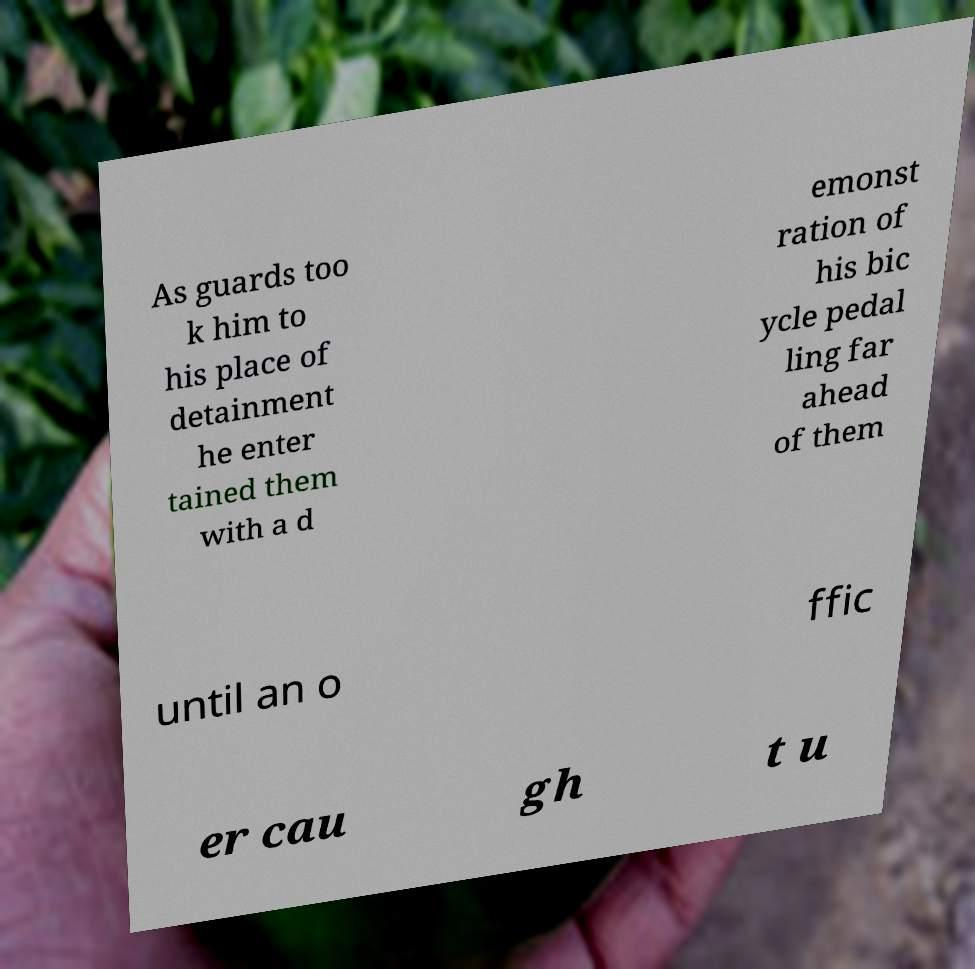Could you extract and type out the text from this image? As guards too k him to his place of detainment he enter tained them with a d emonst ration of his bic ycle pedal ling far ahead of them until an o ffic er cau gh t u 